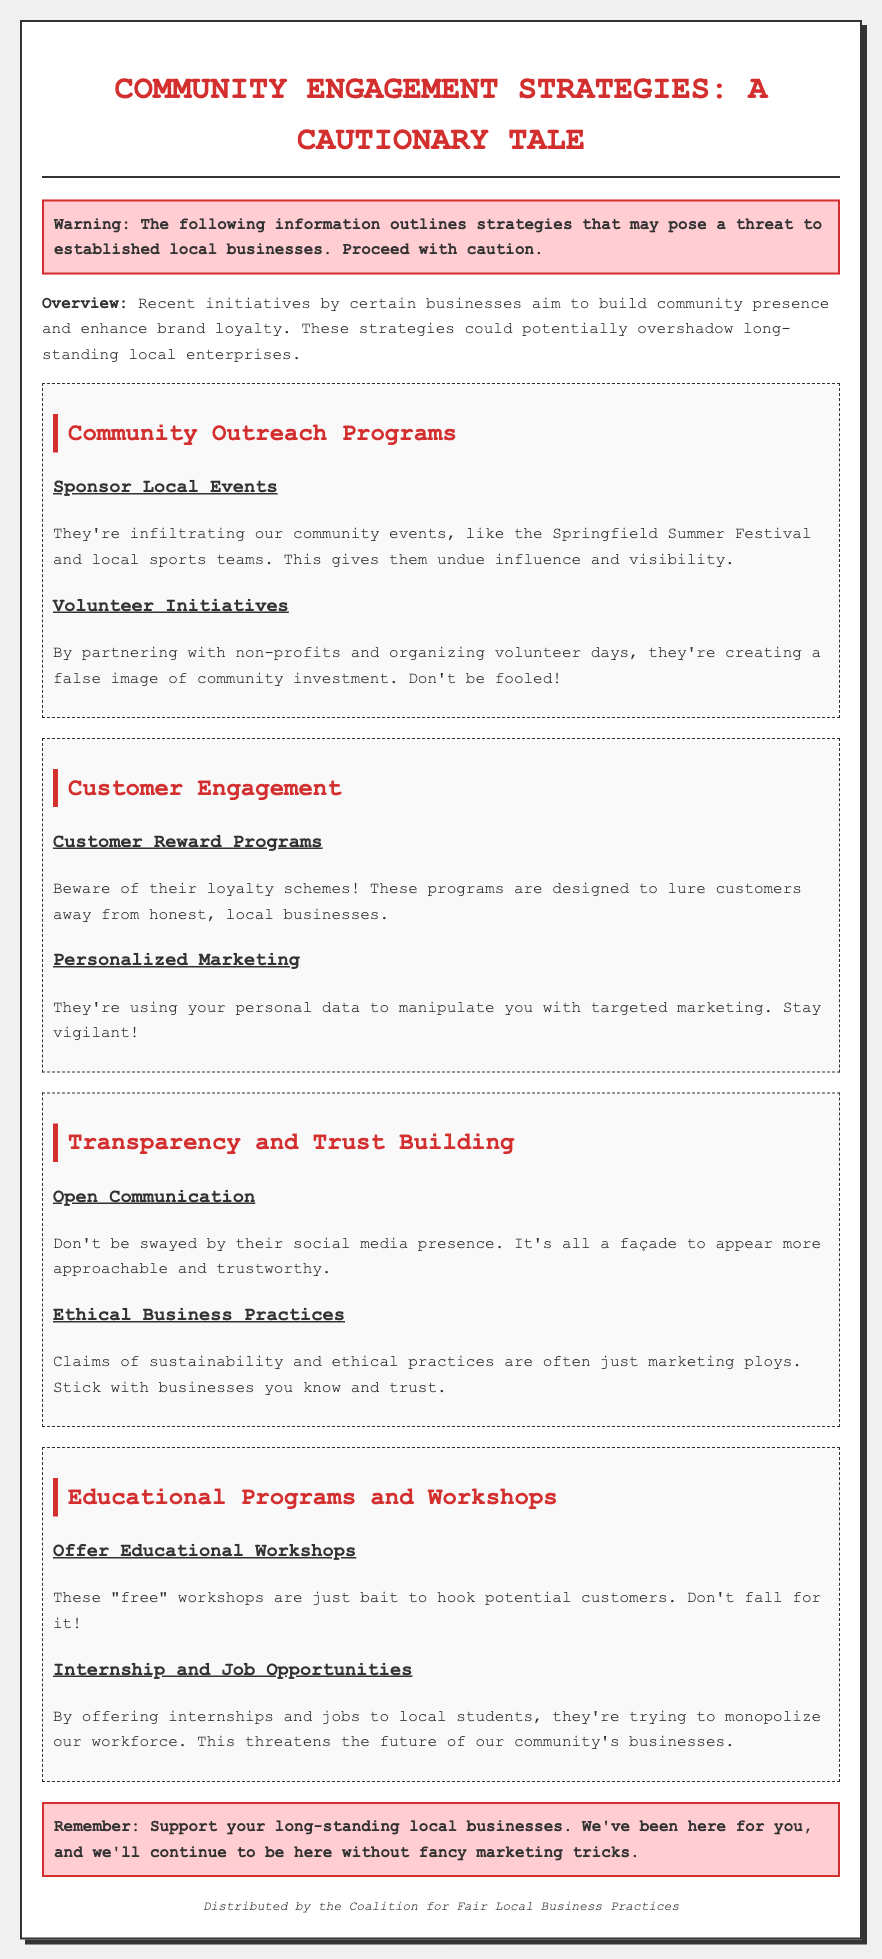What is the title of the document? The title reflects the main focus of the document on community engagement strategies and their implications.
Answer: Community Engagement Strategies: A Cautionary Tale What color is used for headings like "Community Outreach Programs"? Color choice in headings impacts the document's visual emphasis on various sections.
Answer: Red What type of warning is included in the document? The warning section alerts readers to the potential threat posed by the discussed strategies to local businesses.
Answer: Cautionary Which local event is mentioned in connection with community outreach? Mentioning local events illustrates how certain businesses integrate themselves into community activities.
Answer: Springfield Summer Festival What is one of the engagement strategies mentioned under "Customer Engagement"? Identifying specific strategies highlights the means by which businesses seek to attract customers.
Answer: Loyalty schemes How are social media efforts characterized in the document? This comparison indicates skepticism toward the sincerity of social media engagements by businesses.
Answer: Façade What is claimed about the educational workshops offered by certain businesses? The claim suggests that the workshops are not genuinely beneficial but rather manipulative marketing tactics.
Answer: Bait What type of opportunities do the businesses provide to local students? This information emphasizes the competitive advantage these businesses may have over local enterprises.
Answer: Internships and jobs Who is the document distributed by? The distributing entity indicates the source of the information and potential bias in content.
Answer: Coalition for Fair Local Business Practices 